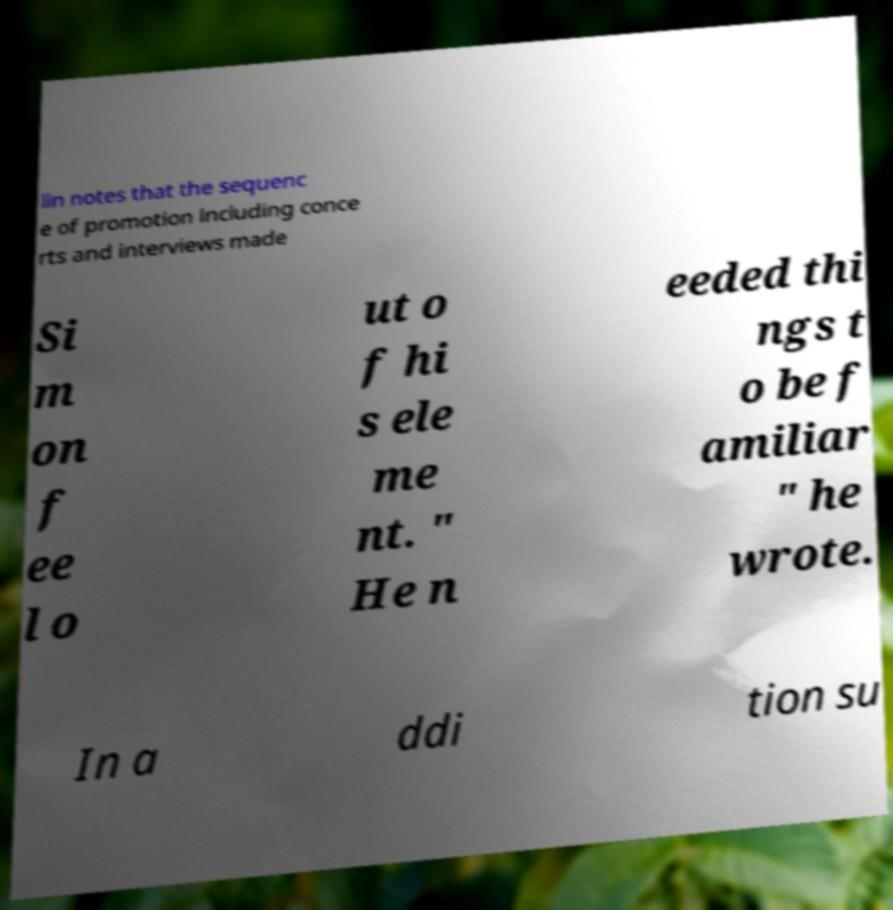What messages or text are displayed in this image? I need them in a readable, typed format. lin notes that the sequenc e of promotion including conce rts and interviews made Si m on f ee l o ut o f hi s ele me nt. " He n eeded thi ngs t o be f amiliar " he wrote. In a ddi tion su 